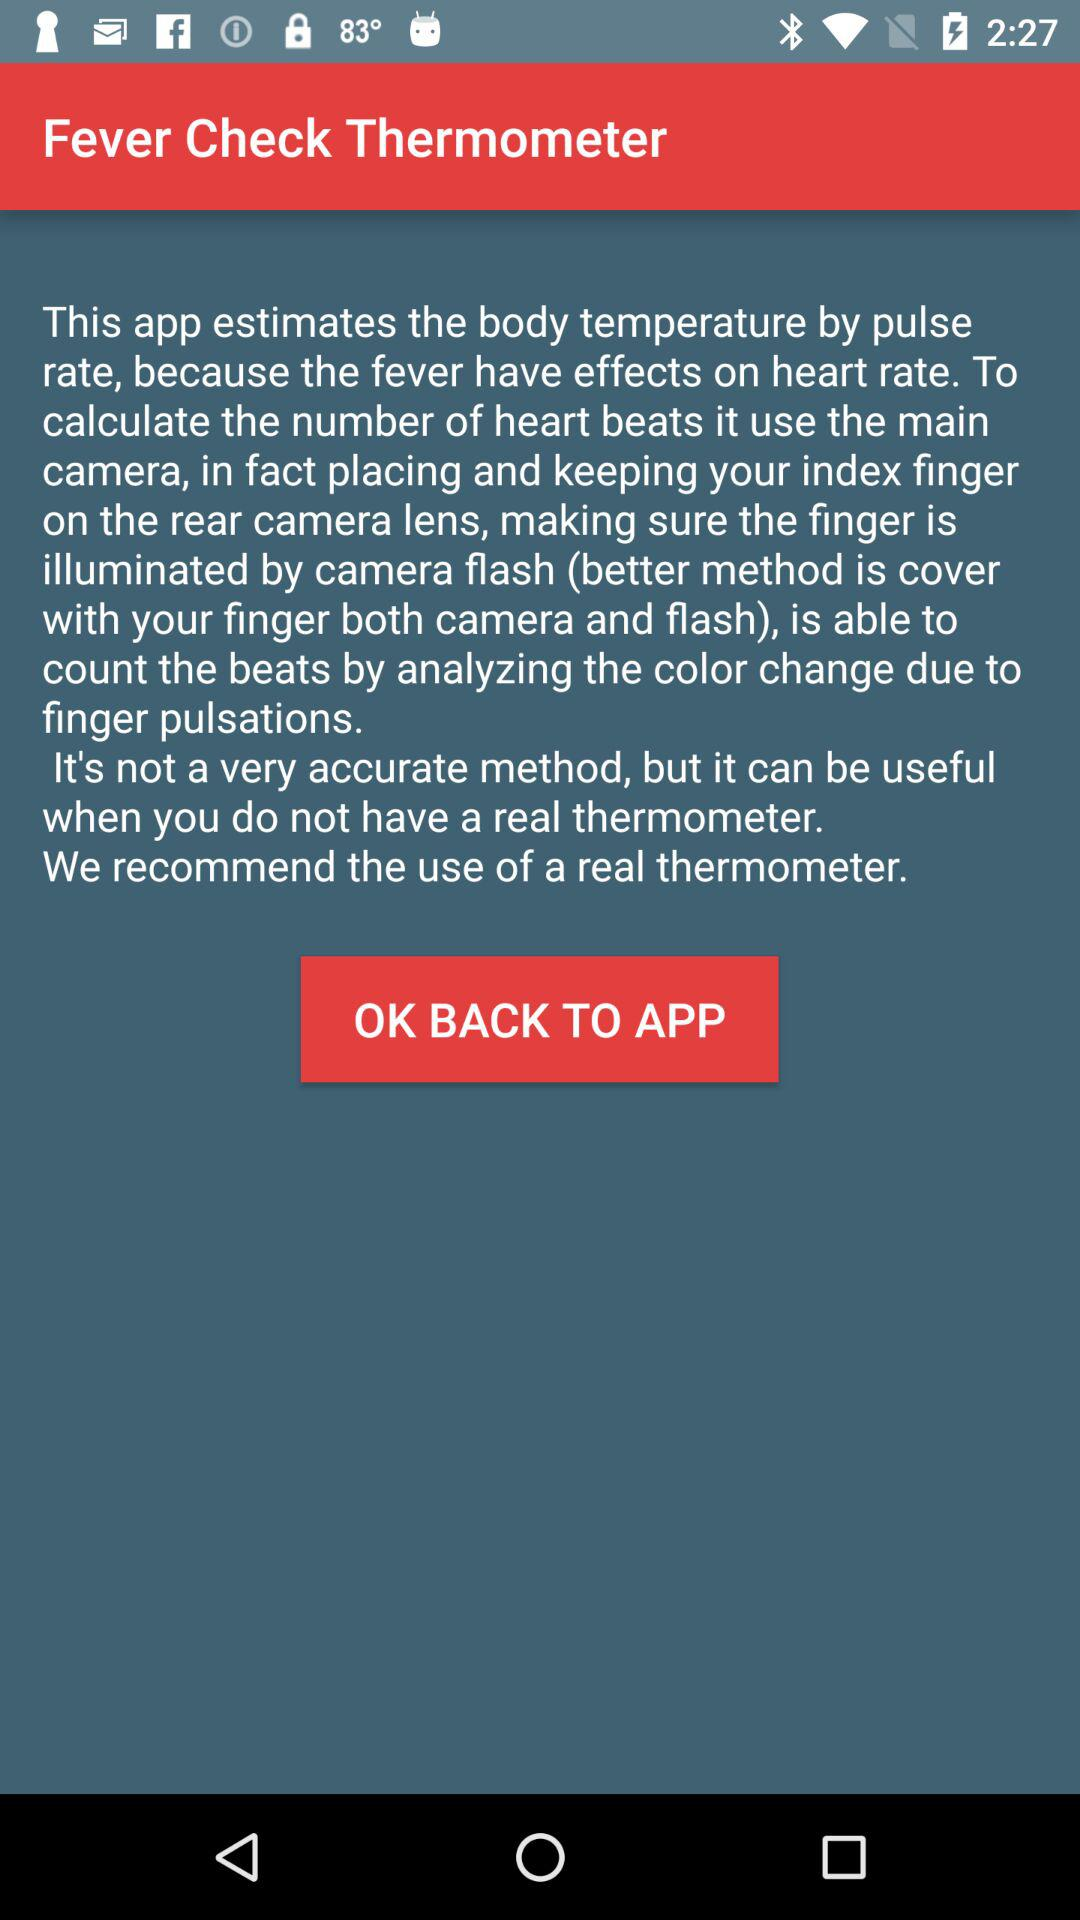What is the name of the application? The application name is "Fever Check Thermometer". 